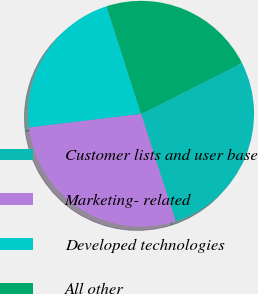Convert chart. <chart><loc_0><loc_0><loc_500><loc_500><pie_chart><fcel>Customer lists and user base<fcel>Marketing- related<fcel>Developed technologies<fcel>All other<nl><fcel>27.47%<fcel>28.02%<fcel>21.98%<fcel>22.53%<nl></chart> 